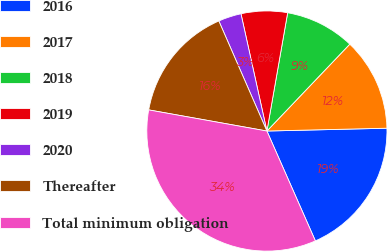Convert chart to OTSL. <chart><loc_0><loc_0><loc_500><loc_500><pie_chart><fcel>2016<fcel>2017<fcel>2018<fcel>2019<fcel>2020<fcel>Thereafter<fcel>Total minimum obligation<nl><fcel>18.76%<fcel>12.5%<fcel>9.36%<fcel>6.23%<fcel>3.09%<fcel>15.63%<fcel>34.43%<nl></chart> 